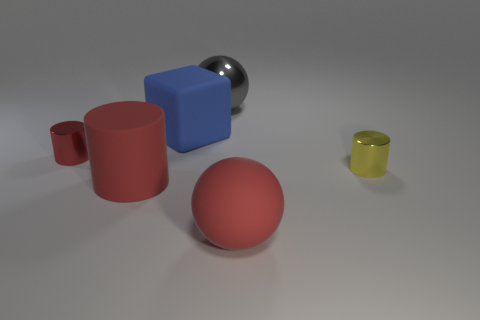What color is the tiny thing that is in front of the metal cylinder that is to the left of the large red rubber ball?
Your answer should be compact. Yellow. Are there any matte blocks of the same color as the shiny sphere?
Offer a very short reply. No. The red rubber thing that is the same size as the red matte cylinder is what shape?
Ensure brevity in your answer.  Sphere. There is a red matte object on the left side of the large red sphere; how many small cylinders are on the right side of it?
Ensure brevity in your answer.  1. Is the big matte ball the same color as the matte cylinder?
Make the answer very short. Yes. There is a red matte object that is on the left side of the sphere that is behind the large red cylinder; what shape is it?
Provide a succinct answer. Cylinder. How big is the rubber object that is to the right of the gray ball?
Make the answer very short. Large. Does the large block have the same material as the yellow thing?
Offer a very short reply. No. There is a blue thing that is the same material as the large red cylinder; what shape is it?
Keep it short and to the point. Cube. Is there any other thing that is the same color as the rubber ball?
Your answer should be compact. Yes. 